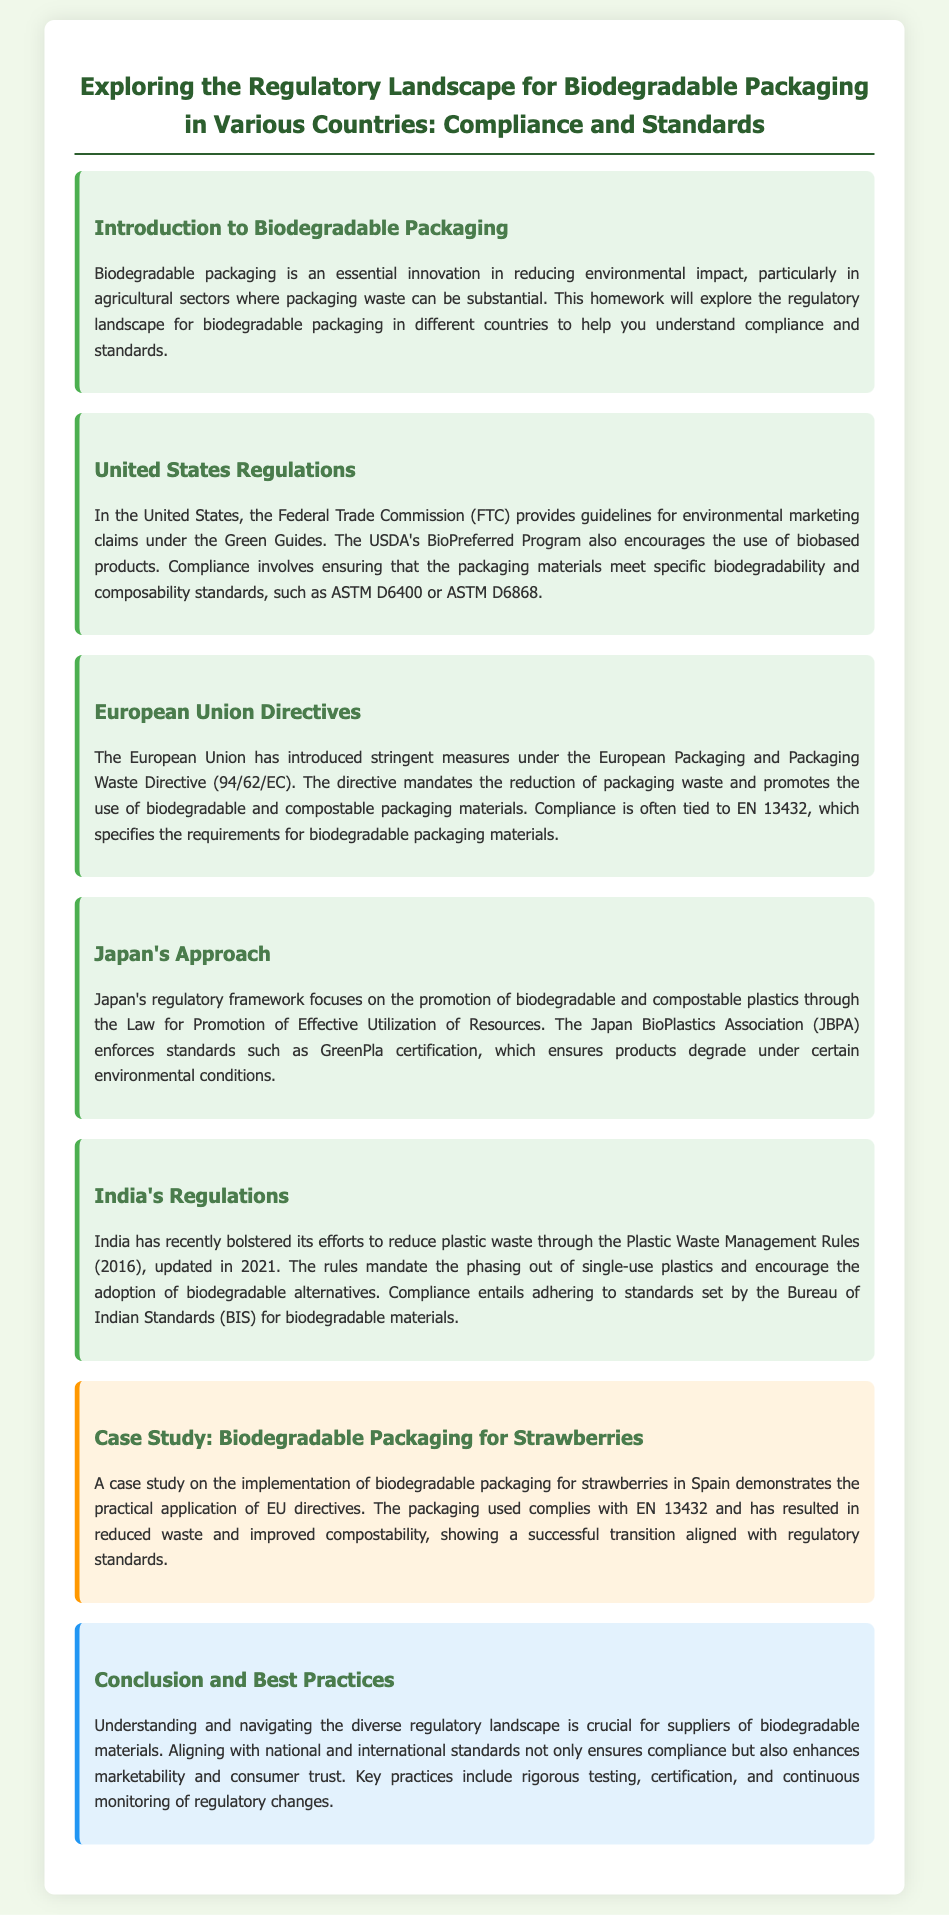What guidelines does the FTC provide? The FTC provides guidelines for environmental marketing claims under the Green Guides.
Answer: Green Guides What program encourages biobased products in the United States? The USDA's program that encourages biobased products is mentioned in the document.
Answer: BioPreferred Program Which directive regulates packaging waste in the European Union? The directive that regulates packaging waste is specified in the document.
Answer: Packaging and Packaging Waste Directive (94/62/EC) What certification is enforced by the Japan BioPlastics Association? The certification enforced by the JBPA to ensure product degradation under certain conditions is stated in the document.
Answer: GreenPla certification What year was the Plastic Waste Management Rules updated in India? The year the rules were updated is referenced in the document.
Answer: 2021 What is the primary focus of Japan's regulatory framework? The primary focus of Japan's regulation is emphasized in the document.
Answer: Promotion of biodegradable and compostable plastics What is a key practice for suppliers of biodegradable materials mentioned in the conclusion? The conclusion highlights important practices for suppliers to adhere to compliance.
Answer: Rigorous testing What was the outcome of the case study on biodegradable packaging for strawberries in Spain? The result of the case study demonstrates the impact of regulatory compliance on packaging.
Answer: Reduced waste and improved compostability 